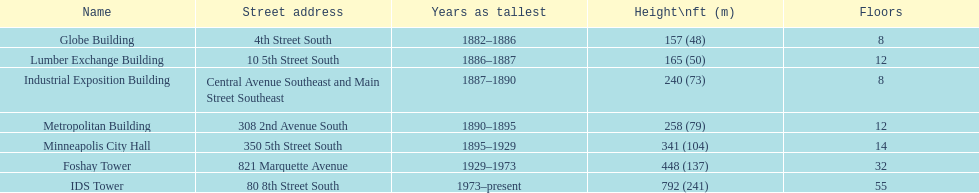Which building has 8 floors and is 240 ft tall? Industrial Exposition Building. 